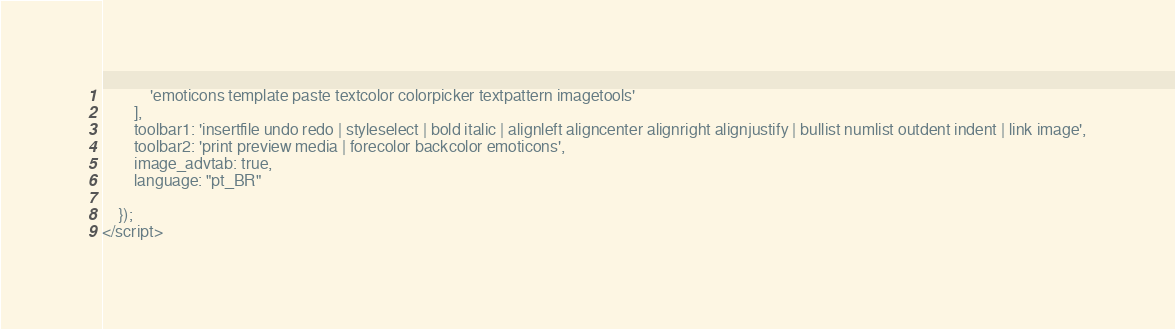<code> <loc_0><loc_0><loc_500><loc_500><_PHP_>            'emoticons template paste textcolor colorpicker textpattern imagetools'
        ],
        toolbar1: 'insertfile undo redo | styleselect | bold italic | alignleft aligncenter alignright alignjustify | bullist numlist outdent indent | link image',
        toolbar2: 'print preview media | forecolor backcolor emoticons',
        image_advtab: true,
        language: "pt_BR"

    });
</script></code> 